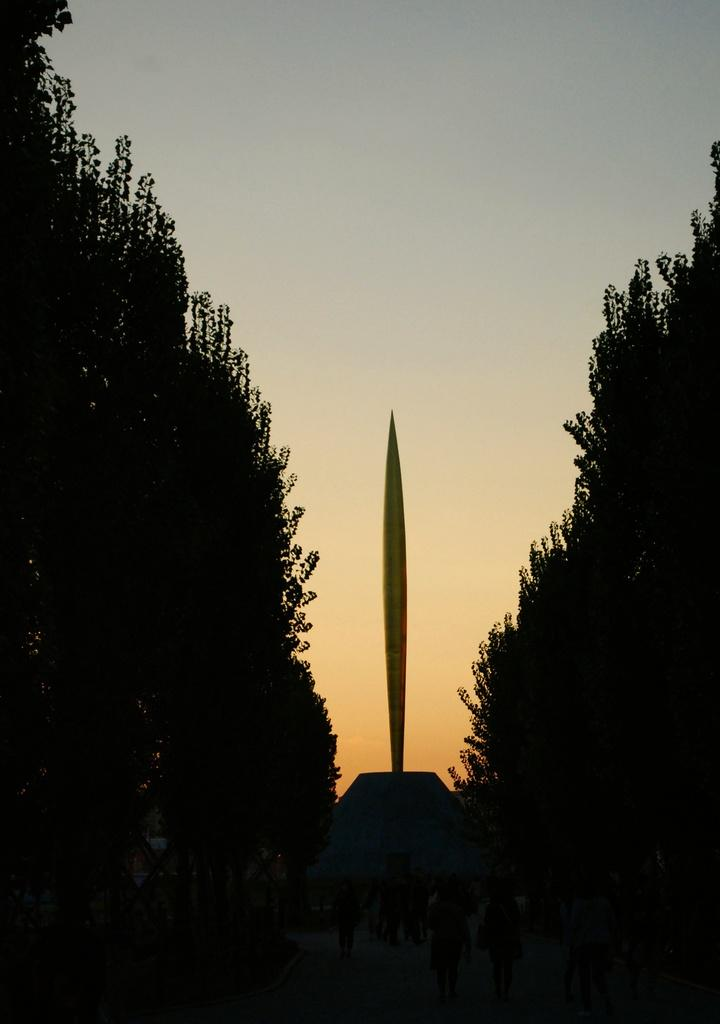What type of vegetation can be seen in the image? There are trees in the image. What structure is visible in the background of the image? There is a pole in the background of the image. What colors are present in the sky in the image? The sky is visible in the image, with colors white and blue. What type of jar can be seen on the railway tracks in the image? There is no jar or railway tracks present in the image. What kind of agreement is being made between the trees in the image? There is no agreement being made between the trees in the image; they are simply standing in their natural state. 